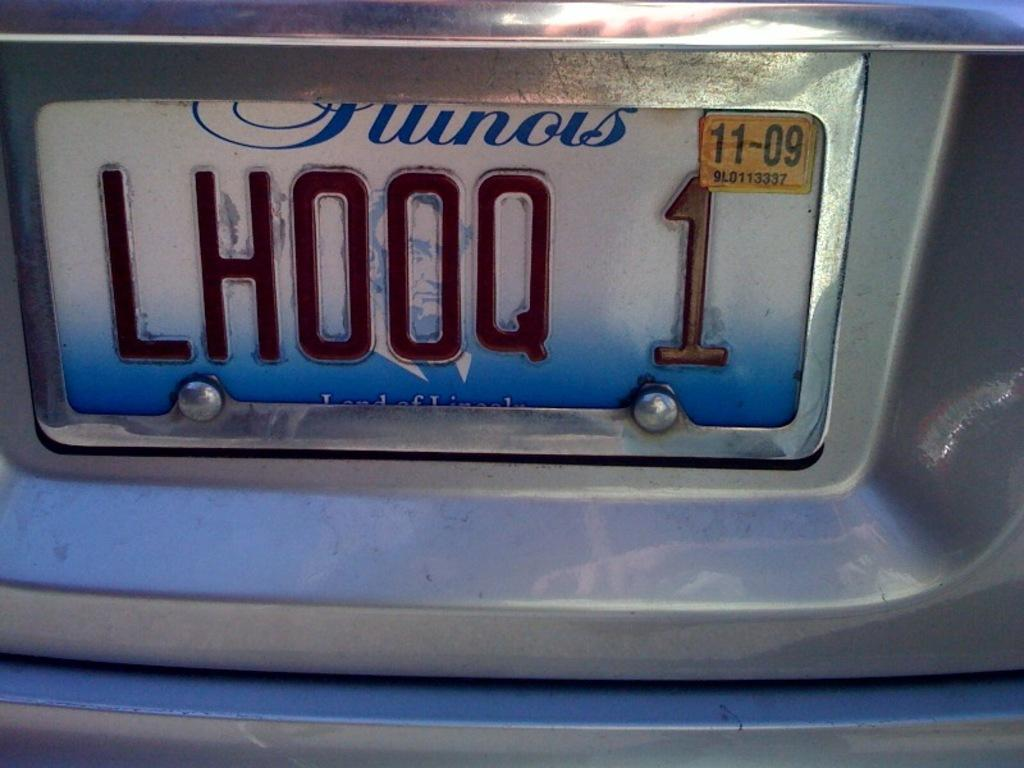<image>
Present a compact description of the photo's key features. A blue car with LH00Q 1 in a silver frame. 